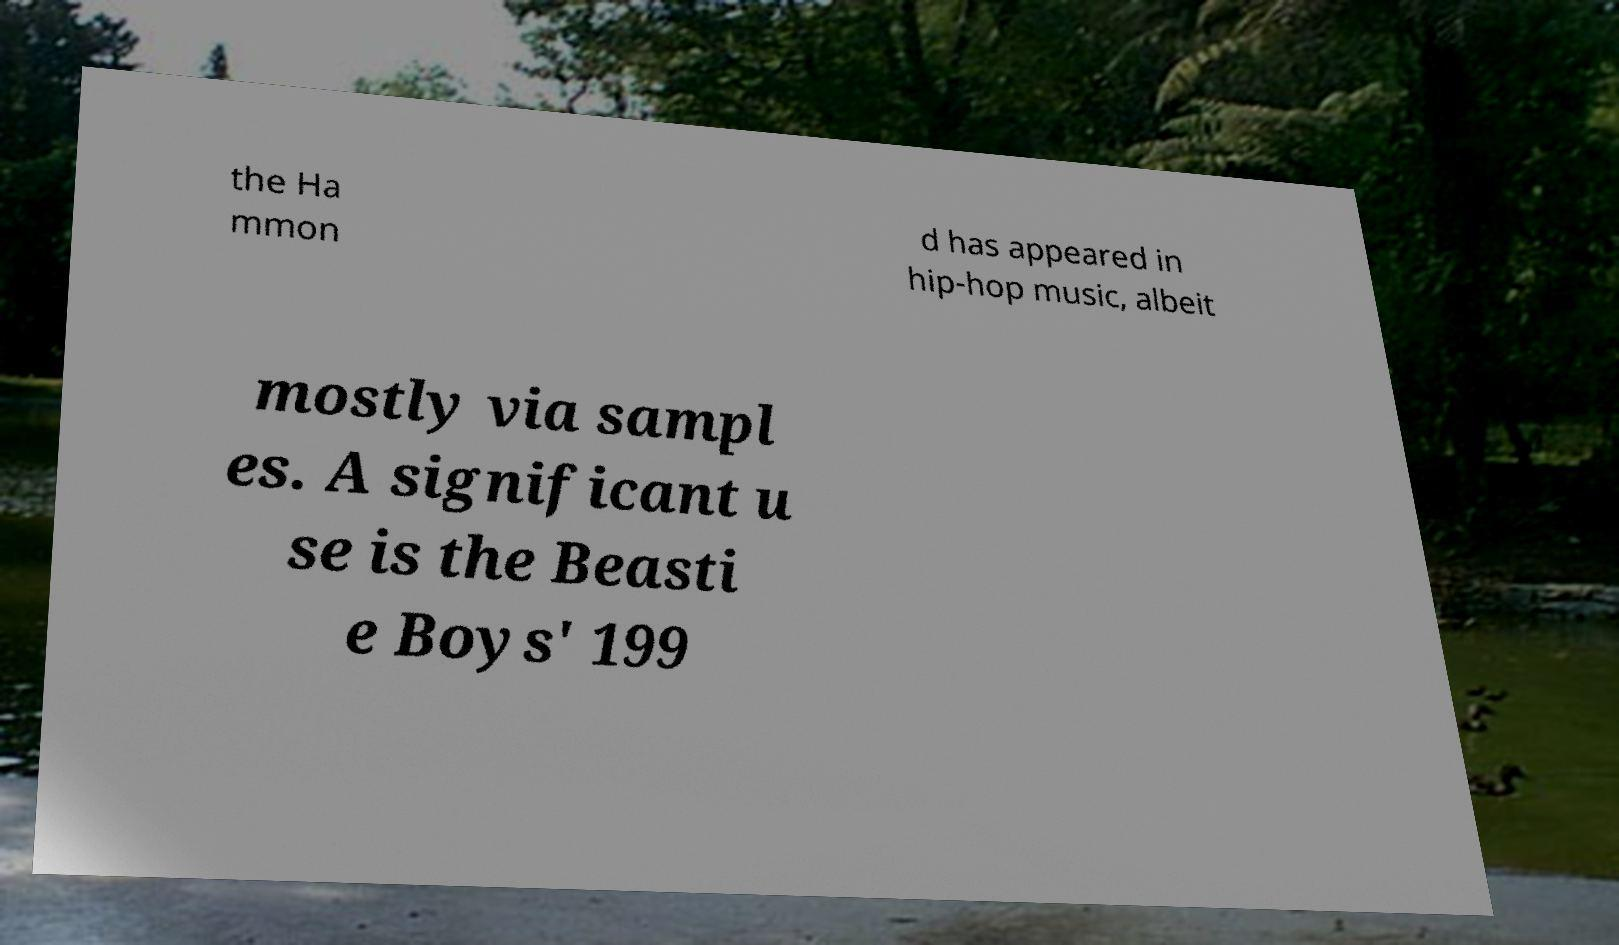I need the written content from this picture converted into text. Can you do that? the Ha mmon d has appeared in hip-hop music, albeit mostly via sampl es. A significant u se is the Beasti e Boys' 199 